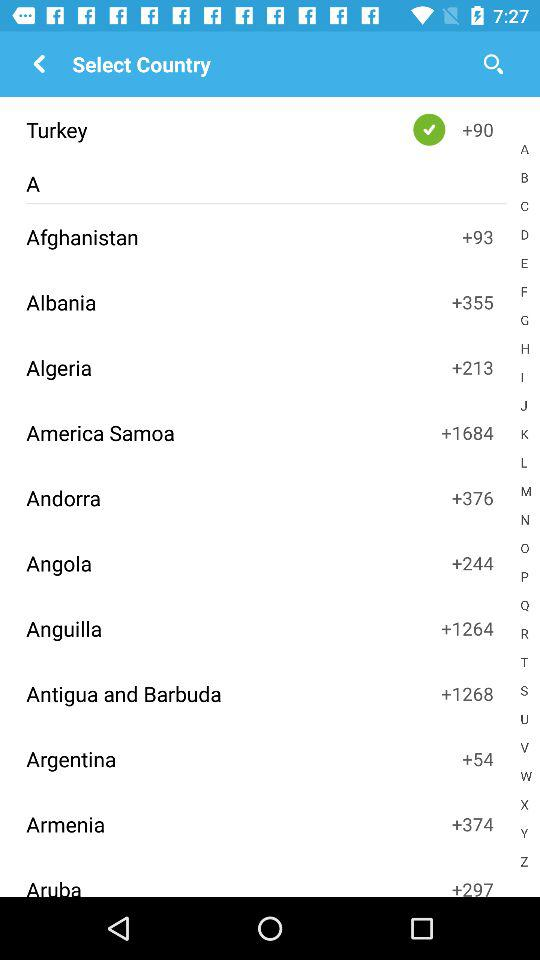Which country's code is +213? The country whose code is +213 is Algeria. 